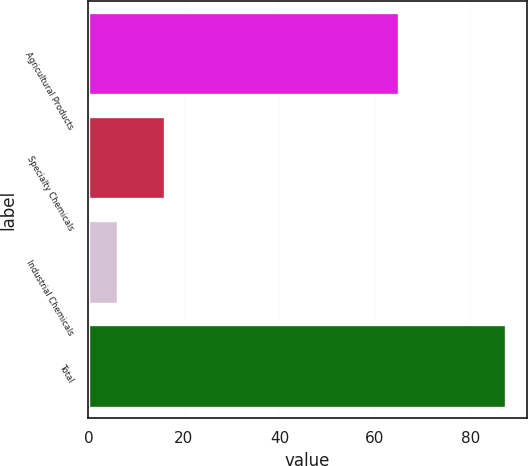<chart> <loc_0><loc_0><loc_500><loc_500><bar_chart><fcel>Agricultural Products<fcel>Specialty Chemicals<fcel>Industrial Chemicals<fcel>Total<nl><fcel>65.1<fcel>16.1<fcel>6.2<fcel>87.4<nl></chart> 